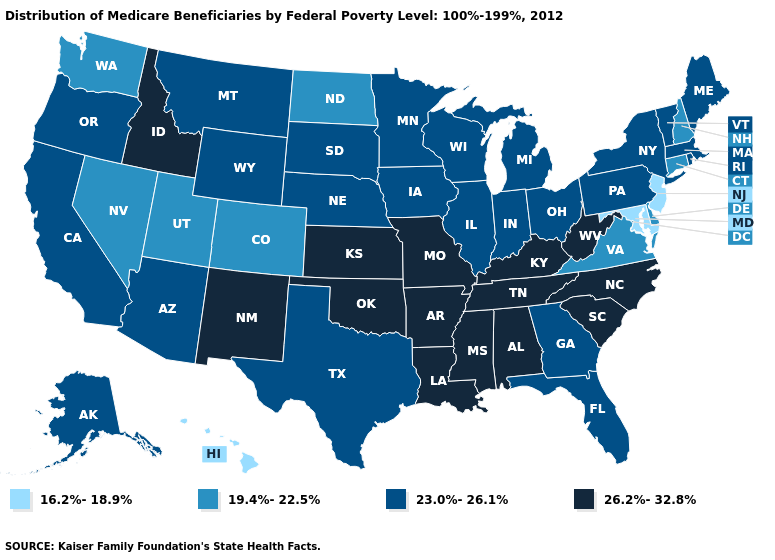What is the lowest value in the West?
Answer briefly. 16.2%-18.9%. Which states have the lowest value in the USA?
Be succinct. Hawaii, Maryland, New Jersey. Name the states that have a value in the range 16.2%-18.9%?
Short answer required. Hawaii, Maryland, New Jersey. What is the highest value in the USA?
Quick response, please. 26.2%-32.8%. What is the value of Virginia?
Short answer required. 19.4%-22.5%. What is the value of Oklahoma?
Answer briefly. 26.2%-32.8%. What is the highest value in the South ?
Be succinct. 26.2%-32.8%. Does the first symbol in the legend represent the smallest category?
Quick response, please. Yes. Does New Jersey have the highest value in the Northeast?
Be succinct. No. What is the value of Oregon?
Give a very brief answer. 23.0%-26.1%. What is the value of New Hampshire?
Short answer required. 19.4%-22.5%. How many symbols are there in the legend?
Quick response, please. 4. Is the legend a continuous bar?
Give a very brief answer. No. What is the lowest value in the South?
Answer briefly. 16.2%-18.9%. What is the value of New Hampshire?
Short answer required. 19.4%-22.5%. 